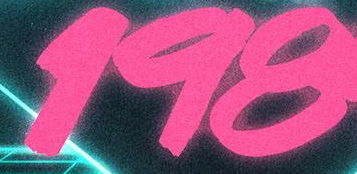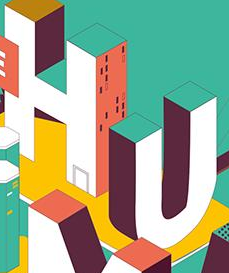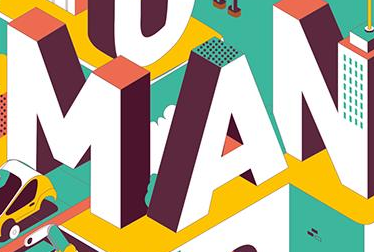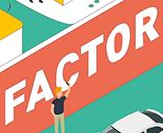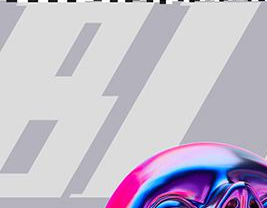Identify the words shown in these images in order, separated by a semicolon. 198; HU; MAN; FACTOR; BI 